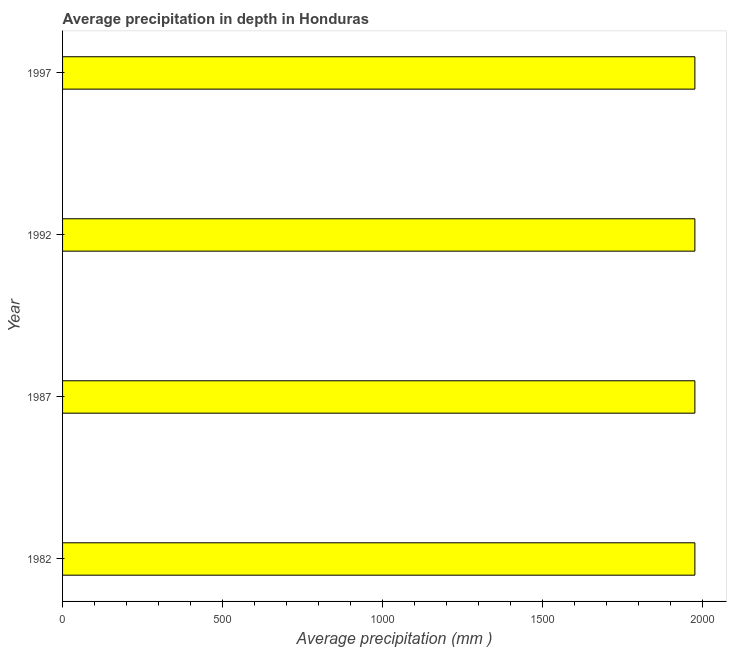Does the graph contain any zero values?
Give a very brief answer. No. Does the graph contain grids?
Your answer should be very brief. No. What is the title of the graph?
Offer a very short reply. Average precipitation in depth in Honduras. What is the label or title of the X-axis?
Keep it short and to the point. Average precipitation (mm ). What is the label or title of the Y-axis?
Give a very brief answer. Year. What is the average precipitation in depth in 1997?
Your response must be concise. 1976. Across all years, what is the maximum average precipitation in depth?
Offer a terse response. 1976. Across all years, what is the minimum average precipitation in depth?
Ensure brevity in your answer.  1976. In which year was the average precipitation in depth maximum?
Keep it short and to the point. 1982. What is the sum of the average precipitation in depth?
Offer a terse response. 7904. What is the difference between the average precipitation in depth in 1982 and 1992?
Your answer should be very brief. 0. What is the average average precipitation in depth per year?
Offer a very short reply. 1976. What is the median average precipitation in depth?
Provide a succinct answer. 1976. In how many years, is the average precipitation in depth greater than 300 mm?
Give a very brief answer. 4. What is the ratio of the average precipitation in depth in 1982 to that in 1997?
Make the answer very short. 1. Is the average precipitation in depth in 1982 less than that in 1997?
Make the answer very short. No. How many bars are there?
Ensure brevity in your answer.  4. Are all the bars in the graph horizontal?
Your answer should be compact. Yes. How many years are there in the graph?
Offer a very short reply. 4. Are the values on the major ticks of X-axis written in scientific E-notation?
Make the answer very short. No. What is the Average precipitation (mm ) in 1982?
Your answer should be compact. 1976. What is the Average precipitation (mm ) in 1987?
Make the answer very short. 1976. What is the Average precipitation (mm ) of 1992?
Make the answer very short. 1976. What is the Average precipitation (mm ) of 1997?
Keep it short and to the point. 1976. What is the difference between the Average precipitation (mm ) in 1982 and 1987?
Keep it short and to the point. 0. What is the difference between the Average precipitation (mm ) in 1982 and 1992?
Keep it short and to the point. 0. What is the ratio of the Average precipitation (mm ) in 1987 to that in 1992?
Offer a very short reply. 1. What is the ratio of the Average precipitation (mm ) in 1992 to that in 1997?
Your answer should be compact. 1. 